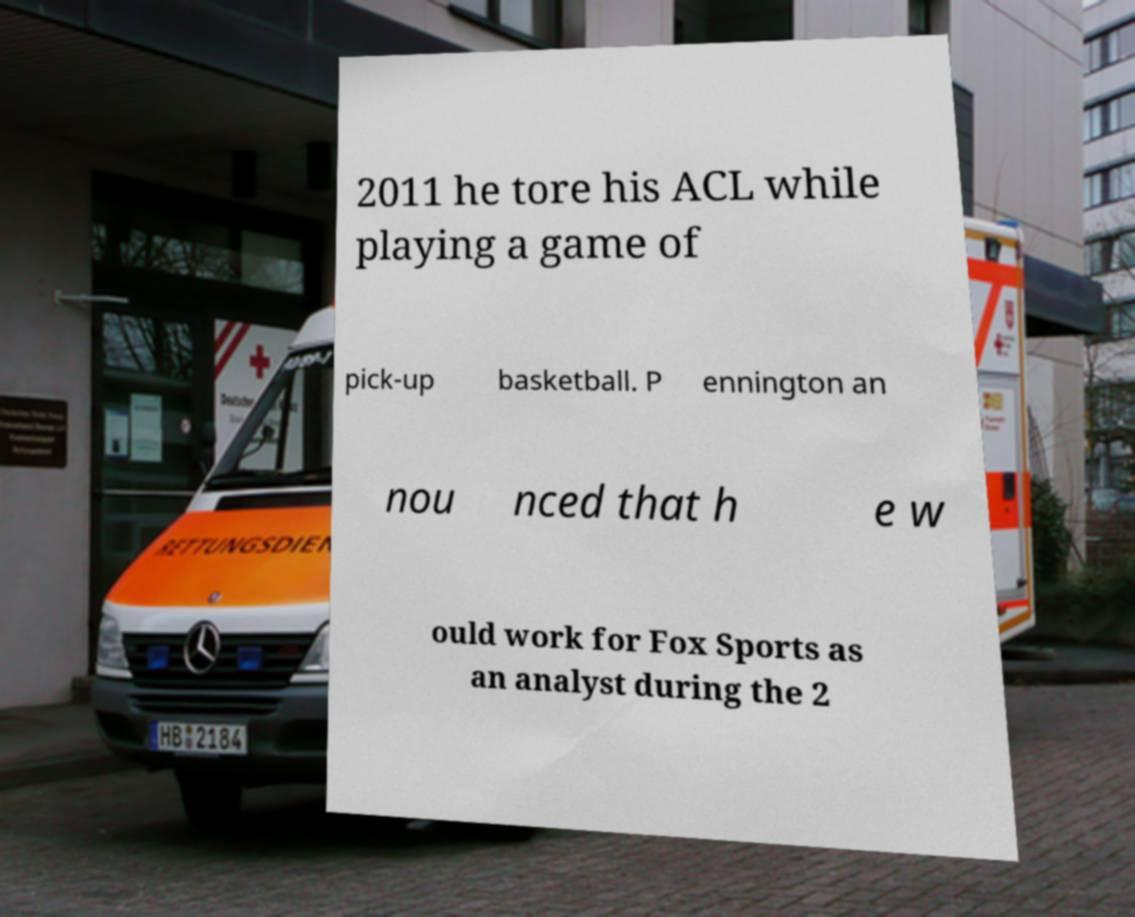Please identify and transcribe the text found in this image. 2011 he tore his ACL while playing a game of pick-up basketball. P ennington an nou nced that h e w ould work for Fox Sports as an analyst during the 2 